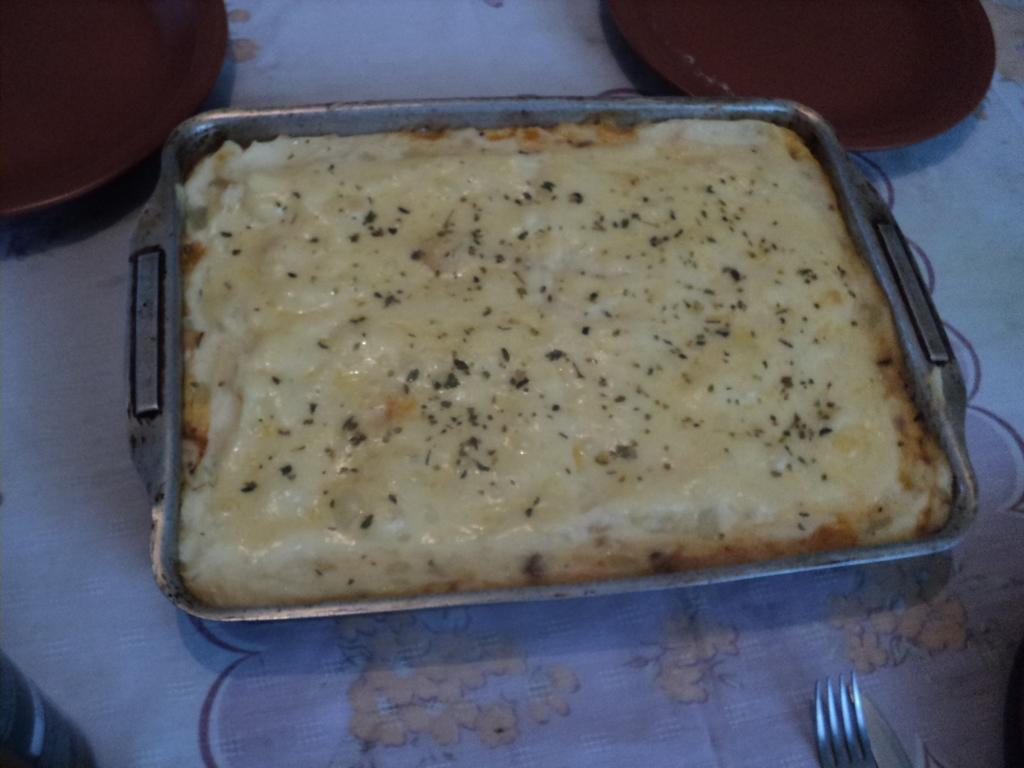What type of dishware can be seen in the image? There are plates in the image. What utensil is present in the image? There is a fork in the image. What is the food item contained in? The food item is in a bowl in the image. Where is the bowl with the food item located? The bowl with the food item is placed on a table. What type of thought can be seen in the image? There are no thoughts visible in the image; it contains physical objects such as plates, a fork, a bowl, and a table. 